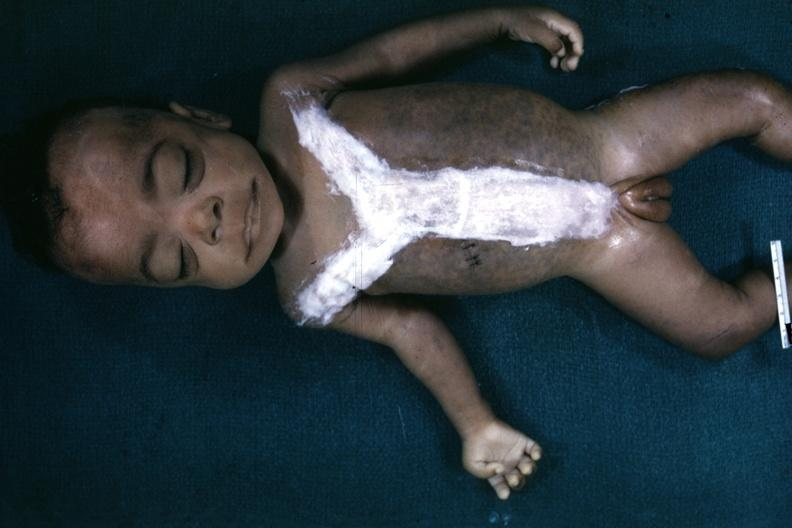s very good representation of mongoloid facies and one hand opened to show simian crease quite good example?
Answer the question using a single word or phrase. Yes 